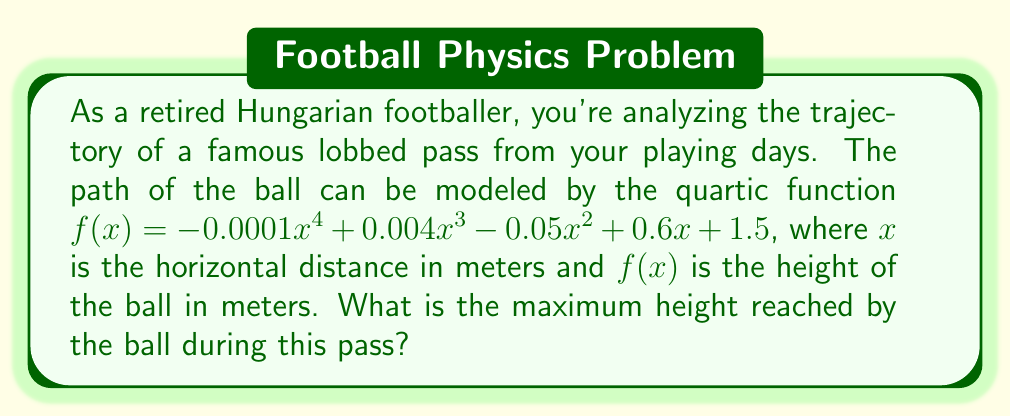Help me with this question. To find the maximum height of the ball, we need to determine the highest point of the quartic function. This occurs at the global maximum of the function within the relevant domain.

Steps to solve:

1) The maximum point occurs where the derivative of the function equals zero. Let's find the derivative:

   $f'(x) = -0.0004x^3 + 0.012x^2 - 0.1x + 0.6$

2) Set the derivative equal to zero:

   $-0.0004x^3 + 0.012x^2 - 0.1x + 0.6 = 0$

3) This is a cubic equation. While it can be solved algebraically, it's complex. In practice, we would use numerical methods or a graphing calculator to find the roots.

4) Using a numerical solver, we find that this equation has three roots: approximately -3.77, 6.25, and 27.52.

5) The root we're interested in is 6.25, as it falls within the realistic range for a football pass.

6) To confirm this is a maximum (not a minimum), we can check the second derivative:

   $f''(x) = -0.0012x^2 + 0.024x - 0.1$

   At $x = 6.25$, $f''(6.25) \approx -0.0725$ which is negative, confirming a maximum.

7) Now we can find the maximum height by plugging x = 6.25 into our original function:

   $f(6.25) = -0.0001(6.25)^4 + 0.004(6.25)^3 - 0.05(6.25)^2 + 0.6(6.25) + 1.5$

8) Calculating this gives us approximately 3.39 meters.
Answer: The maximum height reached by the ball during the pass is approximately 3.39 meters. 